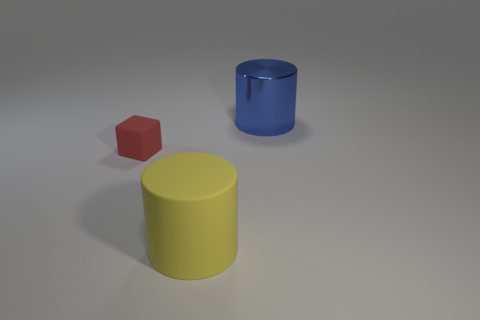Add 3 rubber blocks. How many objects exist? 6 Subtract all cylinders. How many objects are left? 1 Add 2 large matte cylinders. How many large matte cylinders exist? 3 Subtract 0 blue cubes. How many objects are left? 3 Subtract all big objects. Subtract all metallic objects. How many objects are left? 0 Add 3 small matte objects. How many small matte objects are left? 4 